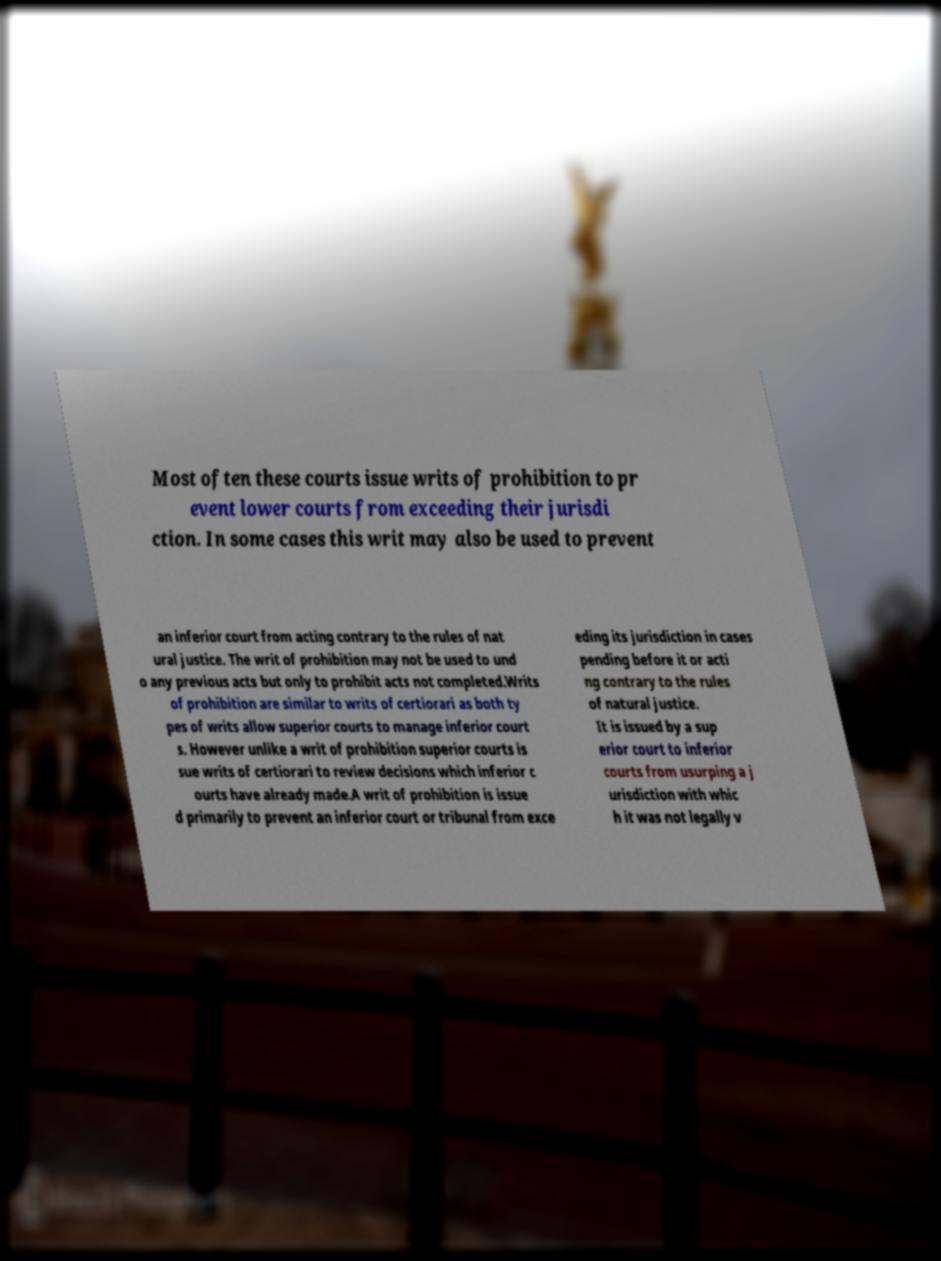Please identify and transcribe the text found in this image. Most often these courts issue writs of prohibition to pr event lower courts from exceeding their jurisdi ction. In some cases this writ may also be used to prevent an inferior court from acting contrary to the rules of nat ural justice. The writ of prohibition may not be used to und o any previous acts but only to prohibit acts not completed.Writs of prohibition are similar to writs of certiorari as both ty pes of writs allow superior courts to manage inferior court s. However unlike a writ of prohibition superior courts is sue writs of certiorari to review decisions which inferior c ourts have already made.A writ of prohibition is issue d primarily to prevent an inferior court or tribunal from exce eding its jurisdiction in cases pending before it or acti ng contrary to the rules of natural justice. It is issued by a sup erior court to inferior courts from usurping a j urisdiction with whic h it was not legally v 